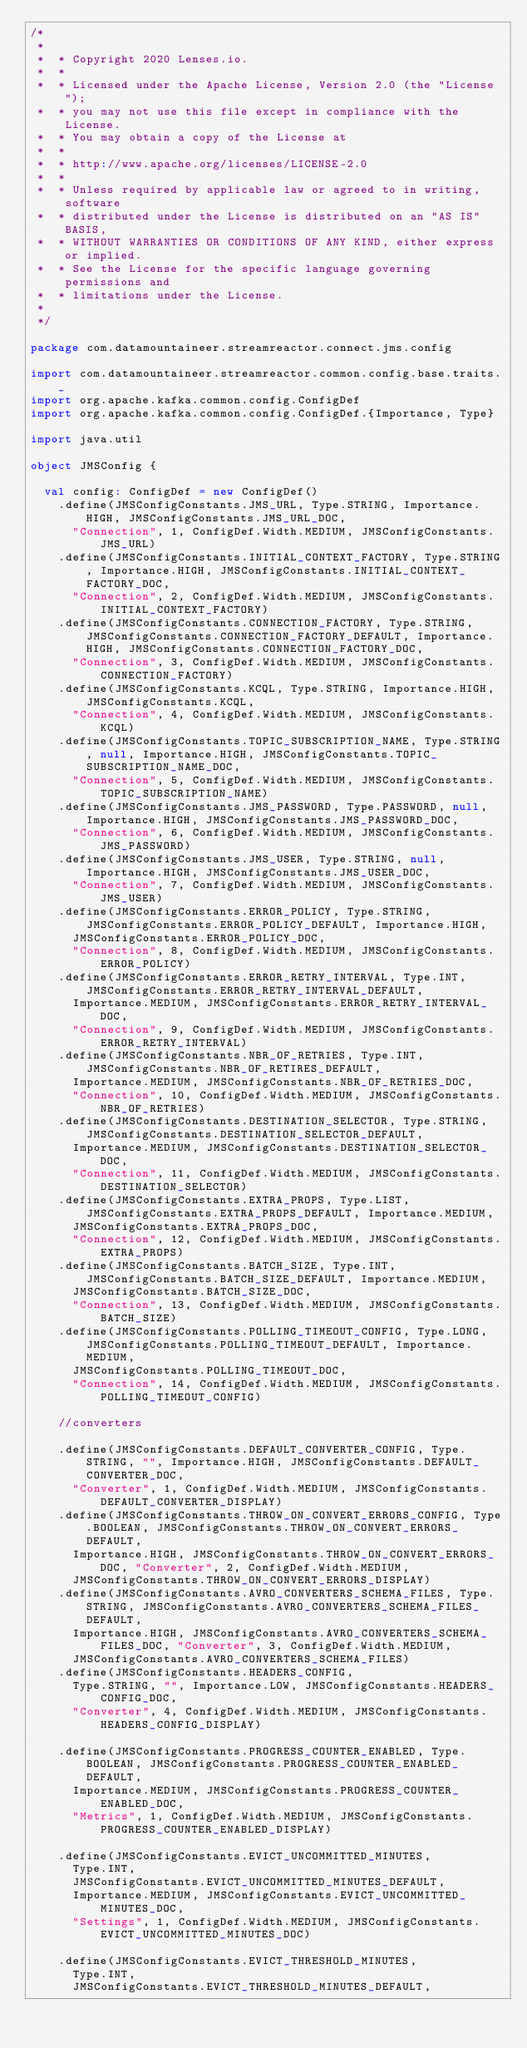<code> <loc_0><loc_0><loc_500><loc_500><_Scala_>/*
 *
 *  * Copyright 2020 Lenses.io.
 *  *
 *  * Licensed under the Apache License, Version 2.0 (the "License");
 *  * you may not use this file except in compliance with the License.
 *  * You may obtain a copy of the License at
 *  *
 *  * http://www.apache.org/licenses/LICENSE-2.0
 *  *
 *  * Unless required by applicable law or agreed to in writing, software
 *  * distributed under the License is distributed on an "AS IS" BASIS,
 *  * WITHOUT WARRANTIES OR CONDITIONS OF ANY KIND, either express or implied.
 *  * See the License for the specific language governing permissions and
 *  * limitations under the License.
 *
 */

package com.datamountaineer.streamreactor.connect.jms.config

import com.datamountaineer.streamreactor.common.config.base.traits._
import org.apache.kafka.common.config.ConfigDef
import org.apache.kafka.common.config.ConfigDef.{Importance, Type}

import java.util

object JMSConfig {

  val config: ConfigDef = new ConfigDef()
    .define(JMSConfigConstants.JMS_URL, Type.STRING, Importance.HIGH, JMSConfigConstants.JMS_URL_DOC,
      "Connection", 1, ConfigDef.Width.MEDIUM, JMSConfigConstants.JMS_URL)
    .define(JMSConfigConstants.INITIAL_CONTEXT_FACTORY, Type.STRING, Importance.HIGH, JMSConfigConstants.INITIAL_CONTEXT_FACTORY_DOC,
      "Connection", 2, ConfigDef.Width.MEDIUM, JMSConfigConstants.INITIAL_CONTEXT_FACTORY)
    .define(JMSConfigConstants.CONNECTION_FACTORY, Type.STRING, JMSConfigConstants.CONNECTION_FACTORY_DEFAULT, Importance.HIGH, JMSConfigConstants.CONNECTION_FACTORY_DOC,
      "Connection", 3, ConfigDef.Width.MEDIUM, JMSConfigConstants.CONNECTION_FACTORY)
    .define(JMSConfigConstants.KCQL, Type.STRING, Importance.HIGH, JMSConfigConstants.KCQL,
      "Connection", 4, ConfigDef.Width.MEDIUM, JMSConfigConstants.KCQL)
    .define(JMSConfigConstants.TOPIC_SUBSCRIPTION_NAME, Type.STRING, null, Importance.HIGH, JMSConfigConstants.TOPIC_SUBSCRIPTION_NAME_DOC,
      "Connection", 5, ConfigDef.Width.MEDIUM, JMSConfigConstants.TOPIC_SUBSCRIPTION_NAME)
    .define(JMSConfigConstants.JMS_PASSWORD, Type.PASSWORD, null, Importance.HIGH, JMSConfigConstants.JMS_PASSWORD_DOC,
      "Connection", 6, ConfigDef.Width.MEDIUM, JMSConfigConstants.JMS_PASSWORD)
    .define(JMSConfigConstants.JMS_USER, Type.STRING, null, Importance.HIGH, JMSConfigConstants.JMS_USER_DOC,
      "Connection", 7, ConfigDef.Width.MEDIUM, JMSConfigConstants.JMS_USER)
    .define(JMSConfigConstants.ERROR_POLICY, Type.STRING, JMSConfigConstants.ERROR_POLICY_DEFAULT, Importance.HIGH,
      JMSConfigConstants.ERROR_POLICY_DOC,
      "Connection", 8, ConfigDef.Width.MEDIUM, JMSConfigConstants.ERROR_POLICY)
    .define(JMSConfigConstants.ERROR_RETRY_INTERVAL, Type.INT, JMSConfigConstants.ERROR_RETRY_INTERVAL_DEFAULT,
      Importance.MEDIUM, JMSConfigConstants.ERROR_RETRY_INTERVAL_DOC,
      "Connection", 9, ConfigDef.Width.MEDIUM, JMSConfigConstants.ERROR_RETRY_INTERVAL)
    .define(JMSConfigConstants.NBR_OF_RETRIES, Type.INT, JMSConfigConstants.NBR_OF_RETIRES_DEFAULT,
      Importance.MEDIUM, JMSConfigConstants.NBR_OF_RETRIES_DOC,
      "Connection", 10, ConfigDef.Width.MEDIUM, JMSConfigConstants.NBR_OF_RETRIES)
    .define(JMSConfigConstants.DESTINATION_SELECTOR, Type.STRING, JMSConfigConstants.DESTINATION_SELECTOR_DEFAULT,
      Importance.MEDIUM, JMSConfigConstants.DESTINATION_SELECTOR_DOC,
      "Connection", 11, ConfigDef.Width.MEDIUM, JMSConfigConstants.DESTINATION_SELECTOR)
    .define(JMSConfigConstants.EXTRA_PROPS, Type.LIST, JMSConfigConstants.EXTRA_PROPS_DEFAULT, Importance.MEDIUM,
      JMSConfigConstants.EXTRA_PROPS_DOC,
      "Connection", 12, ConfigDef.Width.MEDIUM, JMSConfigConstants.EXTRA_PROPS)
    .define(JMSConfigConstants.BATCH_SIZE, Type.INT, JMSConfigConstants.BATCH_SIZE_DEFAULT, Importance.MEDIUM,
      JMSConfigConstants.BATCH_SIZE_DOC,
      "Connection", 13, ConfigDef.Width.MEDIUM, JMSConfigConstants.BATCH_SIZE)
    .define(JMSConfigConstants.POLLING_TIMEOUT_CONFIG, Type.LONG, JMSConfigConstants.POLLING_TIMEOUT_DEFAULT, Importance.MEDIUM,
      JMSConfigConstants.POLLING_TIMEOUT_DOC,
      "Connection", 14, ConfigDef.Width.MEDIUM, JMSConfigConstants.POLLING_TIMEOUT_CONFIG)

    //converters

    .define(JMSConfigConstants.DEFAULT_CONVERTER_CONFIG, Type.STRING, "", Importance.HIGH, JMSConfigConstants.DEFAULT_CONVERTER_DOC,
      "Converter", 1, ConfigDef.Width.MEDIUM, JMSConfigConstants.DEFAULT_CONVERTER_DISPLAY)
    .define(JMSConfigConstants.THROW_ON_CONVERT_ERRORS_CONFIG, Type.BOOLEAN, JMSConfigConstants.THROW_ON_CONVERT_ERRORS_DEFAULT,
      Importance.HIGH, JMSConfigConstants.THROW_ON_CONVERT_ERRORS_DOC, "Converter", 2, ConfigDef.Width.MEDIUM,
      JMSConfigConstants.THROW_ON_CONVERT_ERRORS_DISPLAY)
    .define(JMSConfigConstants.AVRO_CONVERTERS_SCHEMA_FILES, Type.STRING, JMSConfigConstants.AVRO_CONVERTERS_SCHEMA_FILES_DEFAULT,
      Importance.HIGH, JMSConfigConstants.AVRO_CONVERTERS_SCHEMA_FILES_DOC, "Converter", 3, ConfigDef.Width.MEDIUM,
      JMSConfigConstants.AVRO_CONVERTERS_SCHEMA_FILES)
    .define(JMSConfigConstants.HEADERS_CONFIG,
      Type.STRING, "", Importance.LOW, JMSConfigConstants.HEADERS_CONFIG_DOC,
      "Converter", 4, ConfigDef.Width.MEDIUM, JMSConfigConstants.HEADERS_CONFIG_DISPLAY)

    .define(JMSConfigConstants.PROGRESS_COUNTER_ENABLED, Type.BOOLEAN, JMSConfigConstants.PROGRESS_COUNTER_ENABLED_DEFAULT,
      Importance.MEDIUM, JMSConfigConstants.PROGRESS_COUNTER_ENABLED_DOC,
      "Metrics", 1, ConfigDef.Width.MEDIUM, JMSConfigConstants.PROGRESS_COUNTER_ENABLED_DISPLAY)

    .define(JMSConfigConstants.EVICT_UNCOMMITTED_MINUTES,
      Type.INT,
      JMSConfigConstants.EVICT_UNCOMMITTED_MINUTES_DEFAULT,
      Importance.MEDIUM, JMSConfigConstants.EVICT_UNCOMMITTED_MINUTES_DOC,
      "Settings", 1, ConfigDef.Width.MEDIUM, JMSConfigConstants.EVICT_UNCOMMITTED_MINUTES_DOC)

    .define(JMSConfigConstants.EVICT_THRESHOLD_MINUTES,
      Type.INT,
      JMSConfigConstants.EVICT_THRESHOLD_MINUTES_DEFAULT,</code> 